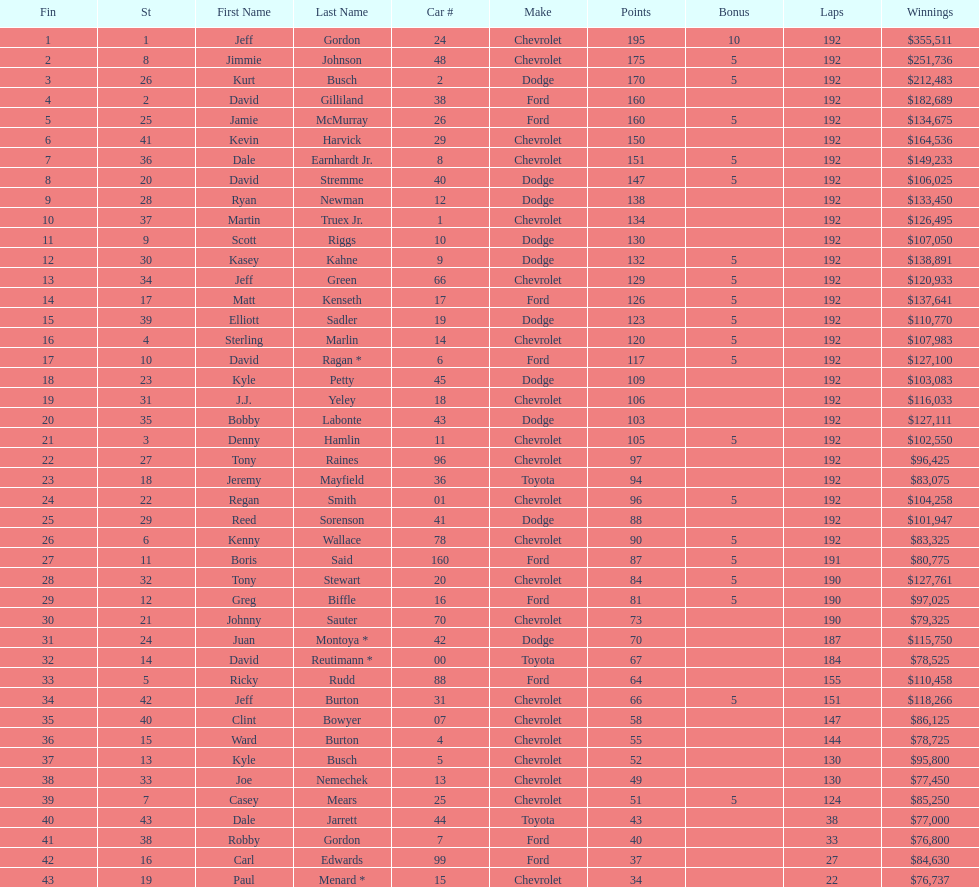What was jimmie johnson's winnings? $251,736. Parse the full table. {'header': ['Fin', 'St', 'First Name', 'Last Name', 'Car #', 'Make', 'Points', 'Bonus', 'Laps', 'Winnings'], 'rows': [['1', '1', 'Jeff', 'Gordon', '24', 'Chevrolet', '195', '10', '192', '$355,511'], ['2', '8', 'Jimmie', 'Johnson', '48', 'Chevrolet', '175', '5', '192', '$251,736'], ['3', '26', 'Kurt', 'Busch', '2', 'Dodge', '170', '5', '192', '$212,483'], ['4', '2', 'David', 'Gilliland', '38', 'Ford', '160', '', '192', '$182,689'], ['5', '25', 'Jamie', 'McMurray', '26', 'Ford', '160', '5', '192', '$134,675'], ['6', '41', 'Kevin', 'Harvick', '29', 'Chevrolet', '150', '', '192', '$164,536'], ['7', '36', 'Dale', 'Earnhardt Jr.', '8', 'Chevrolet', '151', '5', '192', '$149,233'], ['8', '20', 'David', 'Stremme', '40', 'Dodge', '147', '5', '192', '$106,025'], ['9', '28', 'Ryan', 'Newman', '12', 'Dodge', '138', '', '192', '$133,450'], ['10', '37', 'Martin', 'Truex Jr.', '1', 'Chevrolet', '134', '', '192', '$126,495'], ['11', '9', 'Scott', 'Riggs', '10', 'Dodge', '130', '', '192', '$107,050'], ['12', '30', 'Kasey', 'Kahne', '9', 'Dodge', '132', '5', '192', '$138,891'], ['13', '34', 'Jeff', 'Green', '66', 'Chevrolet', '129', '5', '192', '$120,933'], ['14', '17', 'Matt', 'Kenseth', '17', 'Ford', '126', '5', '192', '$137,641'], ['15', '39', 'Elliott', 'Sadler', '19', 'Dodge', '123', '5', '192', '$110,770'], ['16', '4', 'Sterling', 'Marlin', '14', 'Chevrolet', '120', '5', '192', '$107,983'], ['17', '10', 'David', 'Ragan *', '6', 'Ford', '117', '5', '192', '$127,100'], ['18', '23', 'Kyle', 'Petty', '45', 'Dodge', '109', '', '192', '$103,083'], ['19', '31', 'J.J.', 'Yeley', '18', 'Chevrolet', '106', '', '192', '$116,033'], ['20', '35', 'Bobby', 'Labonte', '43', 'Dodge', '103', '', '192', '$127,111'], ['21', '3', 'Denny', 'Hamlin', '11', 'Chevrolet', '105', '5', '192', '$102,550'], ['22', '27', 'Tony', 'Raines', '96', 'Chevrolet', '97', '', '192', '$96,425'], ['23', '18', 'Jeremy', 'Mayfield', '36', 'Toyota', '94', '', '192', '$83,075'], ['24', '22', 'Regan', 'Smith', '01', 'Chevrolet', '96', '5', '192', '$104,258'], ['25', '29', 'Reed', 'Sorenson', '41', 'Dodge', '88', '', '192', '$101,947'], ['26', '6', 'Kenny', 'Wallace', '78', 'Chevrolet', '90', '5', '192', '$83,325'], ['27', '11', 'Boris', 'Said', '160', 'Ford', '87', '5', '191', '$80,775'], ['28', '32', 'Tony', 'Stewart', '20', 'Chevrolet', '84', '5', '190', '$127,761'], ['29', '12', 'Greg', 'Biffle', '16', 'Ford', '81', '5', '190', '$97,025'], ['30', '21', 'Johnny', 'Sauter', '70', 'Chevrolet', '73', '', '190', '$79,325'], ['31', '24', 'Juan', 'Montoya *', '42', 'Dodge', '70', '', '187', '$115,750'], ['32', '14', 'David', 'Reutimann *', '00', 'Toyota', '67', '', '184', '$78,525'], ['33', '5', 'Ricky', 'Rudd', '88', 'Ford', '64', '', '155', '$110,458'], ['34', '42', 'Jeff', 'Burton', '31', 'Chevrolet', '66', '5', '151', '$118,266'], ['35', '40', 'Clint', 'Bowyer', '07', 'Chevrolet', '58', '', '147', '$86,125'], ['36', '15', 'Ward', 'Burton', '4', 'Chevrolet', '55', '', '144', '$78,725'], ['37', '13', 'Kyle', 'Busch', '5', 'Chevrolet', '52', '', '130', '$95,800'], ['38', '33', 'Joe', 'Nemechek', '13', 'Chevrolet', '49', '', '130', '$77,450'], ['39', '7', 'Casey', 'Mears', '25', 'Chevrolet', '51', '5', '124', '$85,250'], ['40', '43', 'Dale', 'Jarrett', '44', 'Toyota', '43', '', '38', '$77,000'], ['41', '38', 'Robby', 'Gordon', '7', 'Ford', '40', '', '33', '$76,800'], ['42', '16', 'Carl', 'Edwards', '99', 'Ford', '37', '', '27', '$84,630'], ['43', '19', 'Paul', 'Menard *', '15', 'Chevrolet', '34', '', '22', '$76,737']]} 